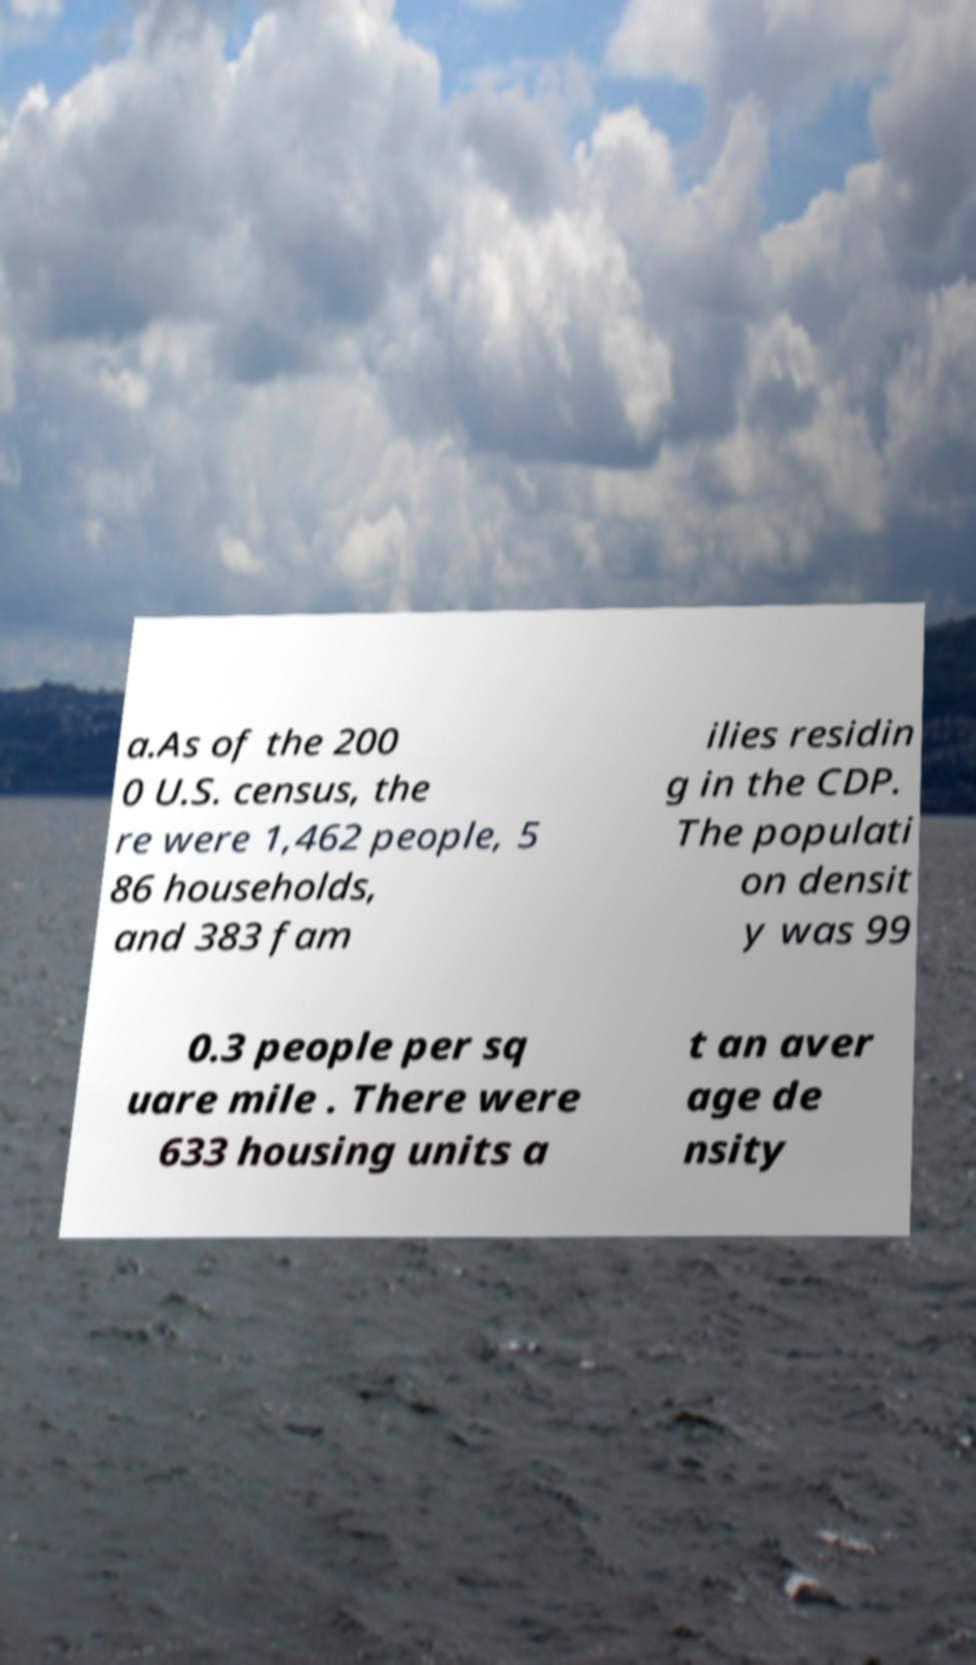Can you read and provide the text displayed in the image?This photo seems to have some interesting text. Can you extract and type it out for me? a.As of the 200 0 U.S. census, the re were 1,462 people, 5 86 households, and 383 fam ilies residin g in the CDP. The populati on densit y was 99 0.3 people per sq uare mile . There were 633 housing units a t an aver age de nsity 